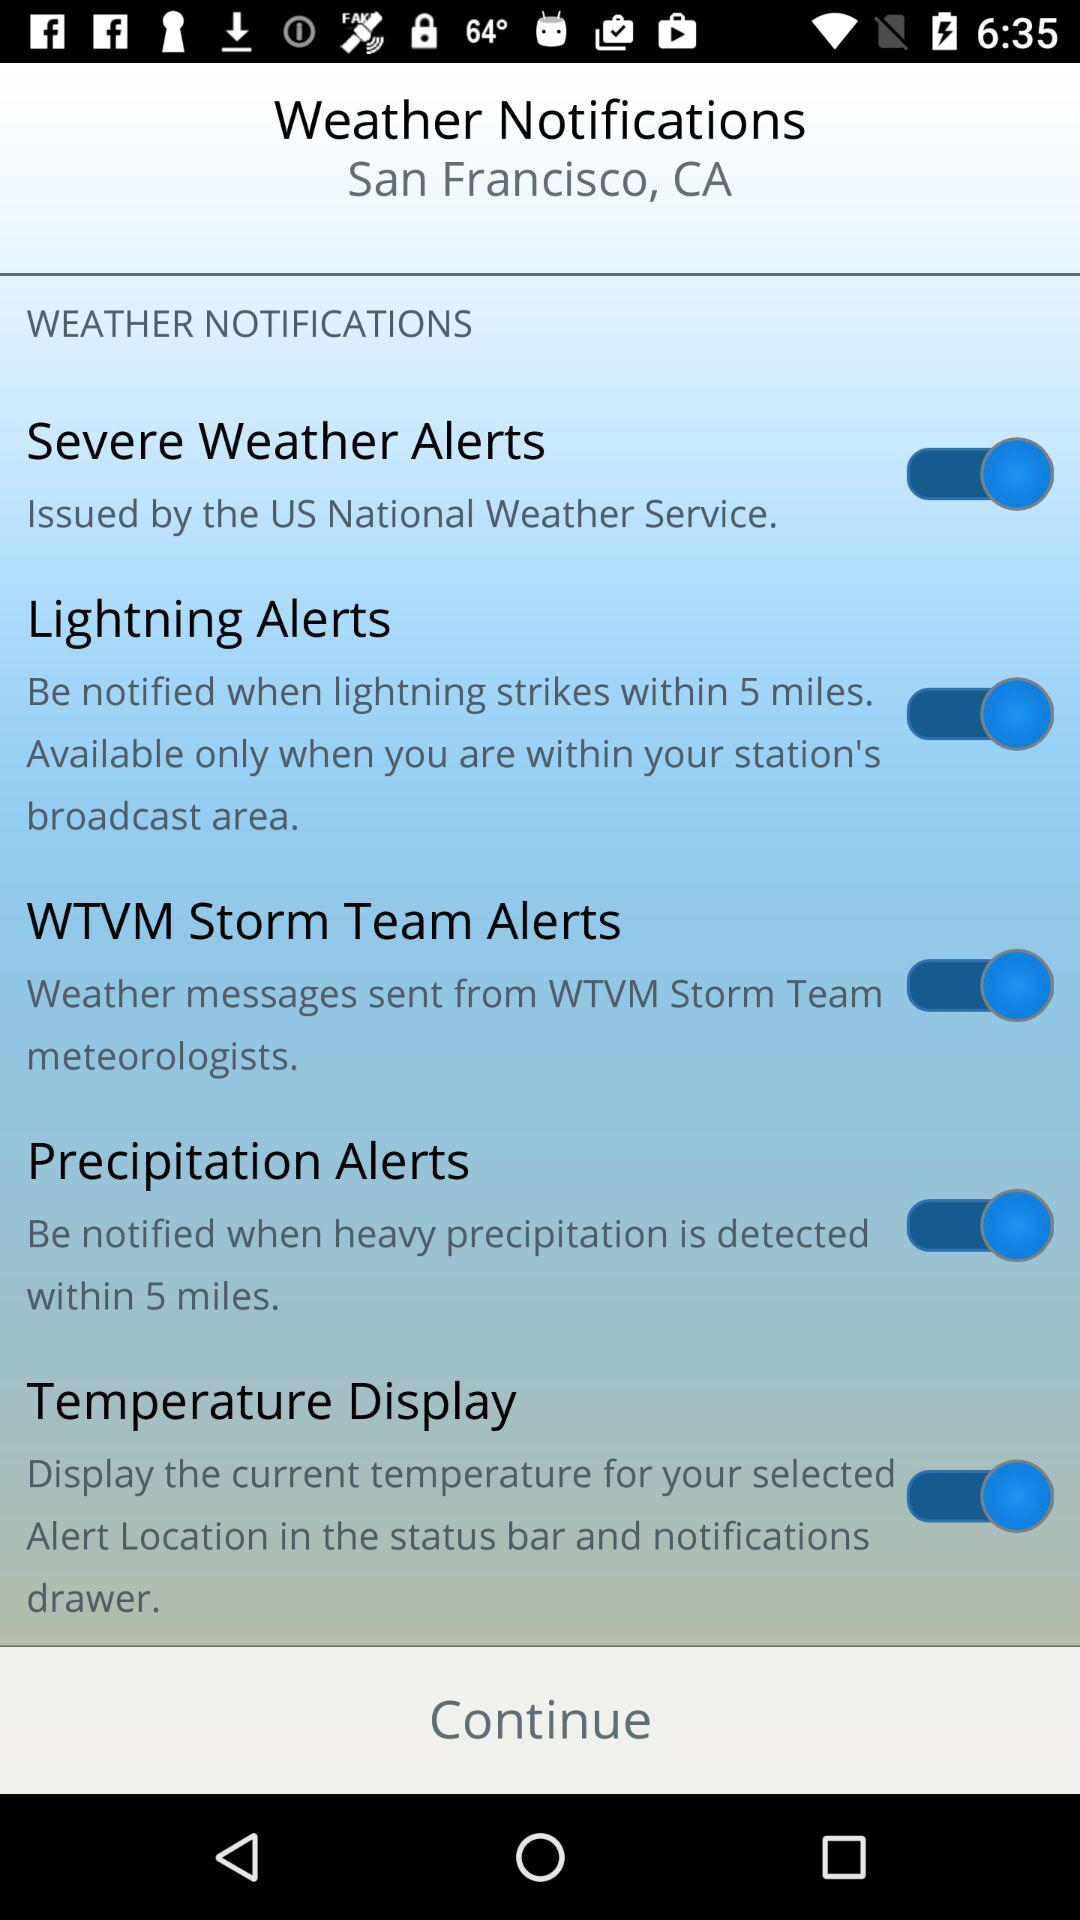How many alerts have a switch?
Answer the question using a single word or phrase. 4 